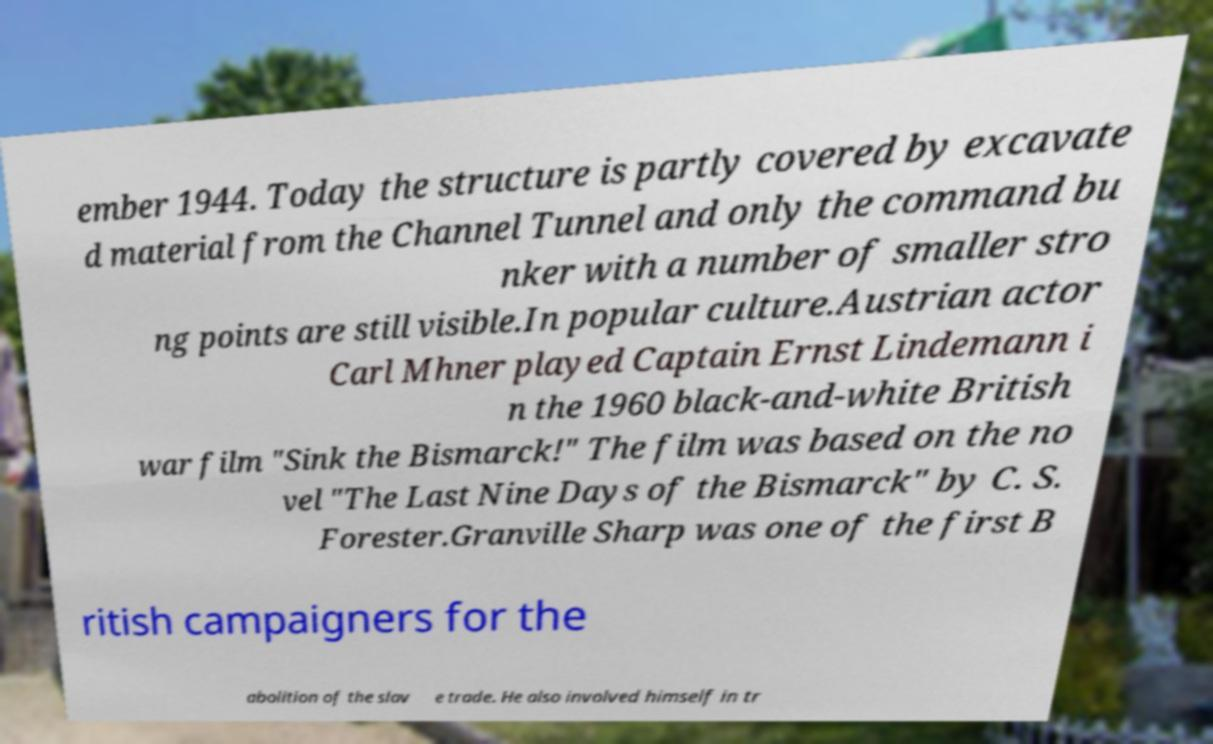I need the written content from this picture converted into text. Can you do that? ember 1944. Today the structure is partly covered by excavate d material from the Channel Tunnel and only the command bu nker with a number of smaller stro ng points are still visible.In popular culture.Austrian actor Carl Mhner played Captain Ernst Lindemann i n the 1960 black-and-white British war film "Sink the Bismarck!" The film was based on the no vel "The Last Nine Days of the Bismarck" by C. S. Forester.Granville Sharp was one of the first B ritish campaigners for the abolition of the slav e trade. He also involved himself in tr 